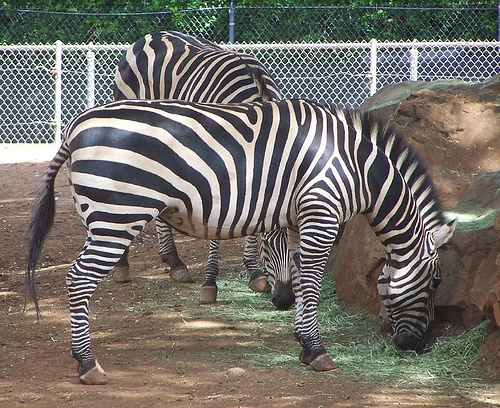Describe the objects in this image and their specific colors. I can see zebra in darkgreen, black, lightgray, gray, and darkgray tones and zebra in darkgreen, black, gray, darkgray, and lightgray tones in this image. 